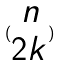Convert formula to latex. <formula><loc_0><loc_0><loc_500><loc_500>( \begin{matrix} n \\ 2 k \end{matrix} )</formula> 